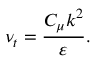<formula> <loc_0><loc_0><loc_500><loc_500>\nu _ { t } = \frac { C _ { \mu } k ^ { 2 } } { \varepsilon } .</formula> 